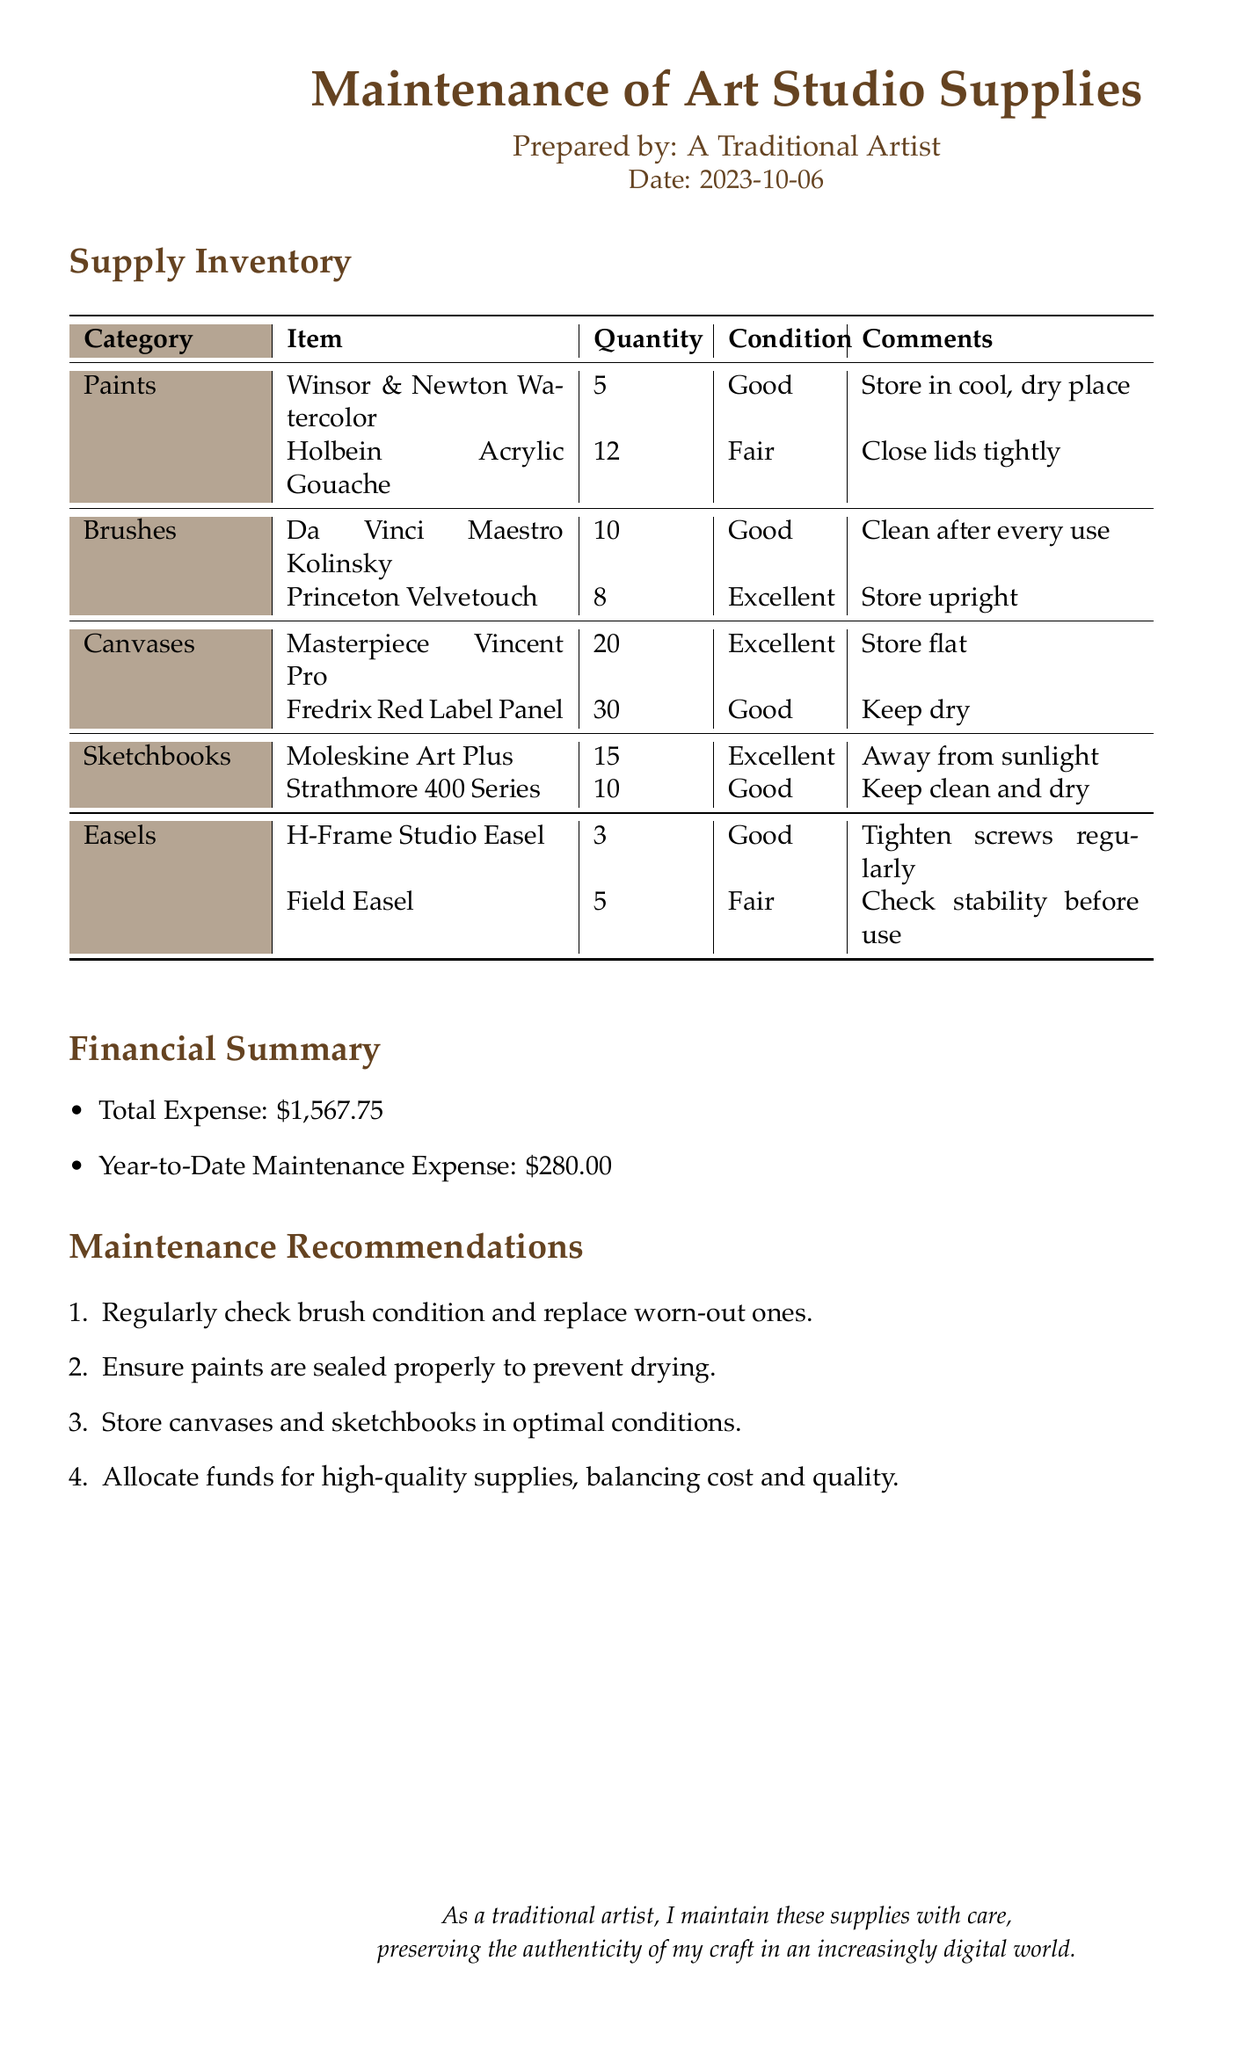What is the total expense? The total expense is stated in the financial summary section.
Answer: $1,567.75 How many categories of supplies are listed? The supply inventory section lists several categories.
Answer: 5 What is the condition of the Moleskine Art Plus sketchbooks? The condition of the sketchbooks is mentioned in the inventory table.
Answer: Excellent What item has the highest quantity? This can be found by comparing the quantities listed in the inventory.
Answer: Fredrix Red Label Panel What is the year-to-date maintenance expense? The year-to-date maintenance expense is specified in the financial summary.
Answer: $280.00 What recommendation is made regarding brush maintenance? Recommendations are provided in a list; this can be found in the maintenance recommendations section.
Answer: Regularly check brush condition and replace worn-out ones How many Da Vinci Maestro Kolinsky brushes are there? The quantity is detailed in the supply inventory table.
Answer: 10 What is one condition for storing canvases? The conditions for storing items are provided in the comments of the supply inventory.
Answer: Store flat What is the condition of the Field Easel? The condition of the easel is noted in the inventory table.
Answer: Fair 